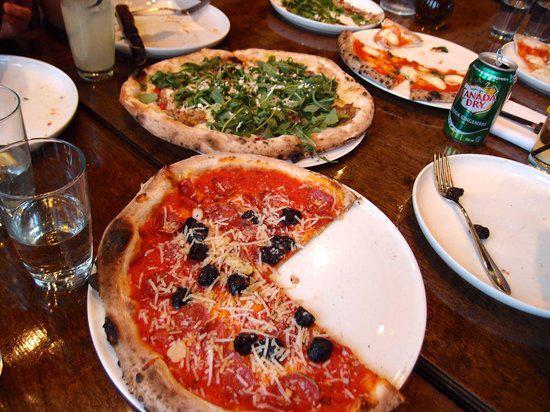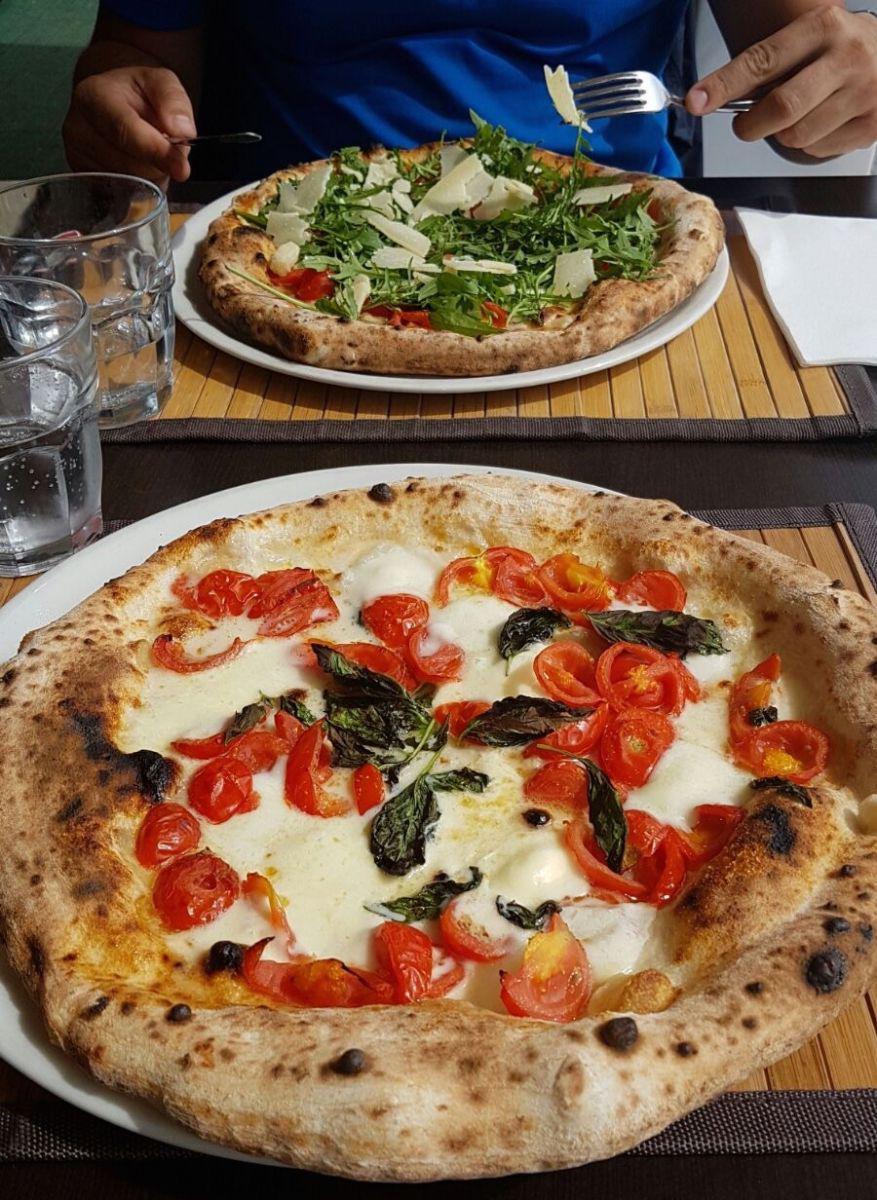The first image is the image on the left, the second image is the image on the right. Examine the images to the left and right. Is the description "Each image contains exactly one rounded pizza with no slices missing." accurate? Answer yes or no. No. 